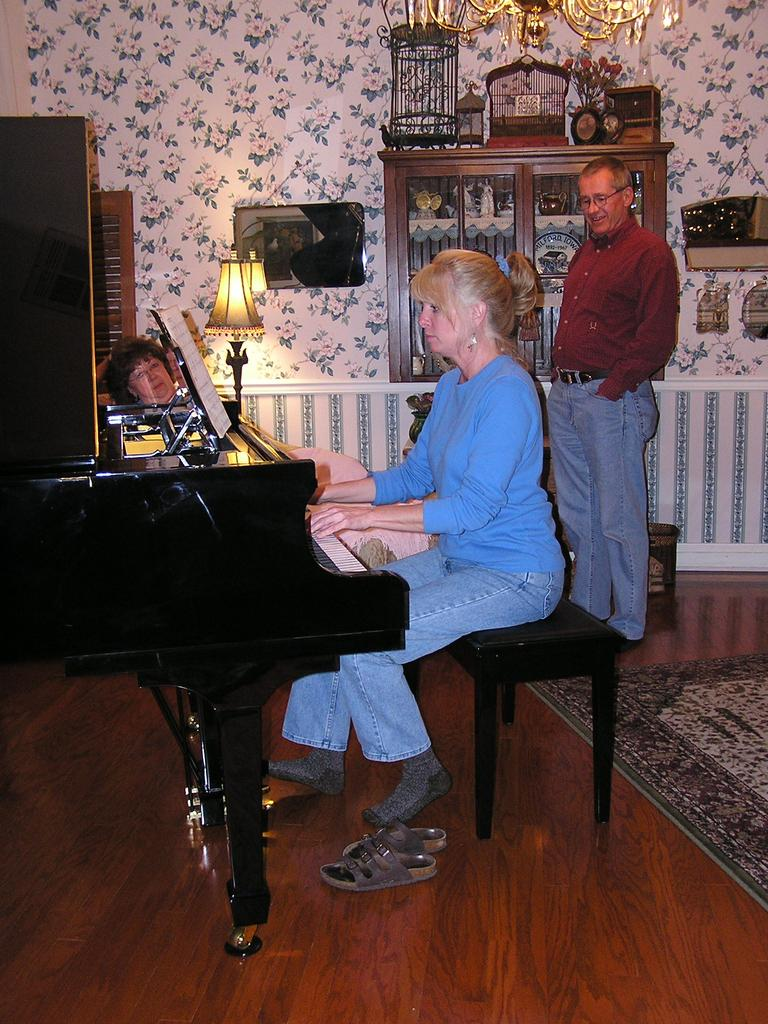Who is the main subject in the image? There is a woman in the image. What is the woman wearing? The woman is wearing a blue t-shirt. What is the woman doing in the image? The woman is playing piano. What can be seen in the background of the image? There is a wall, lamps, and cupboards in the background of the image. Are there any other people present in the image? Yes, there is a person standing in the background of the image. What type of doll is sitting on top of the piano in the image? There is no doll present on top of the piano in the image. What kind of shade is covering the lamps in the background of the image? There is no shade covering the lamps in the image; the lamps are visible without any covering. 